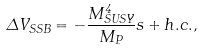Convert formula to latex. <formula><loc_0><loc_0><loc_500><loc_500>\Delta V _ { S S B } = - \frac { M _ { S U S Y } ^ { 4 } } { M _ { P } } s + h . c . ,</formula> 